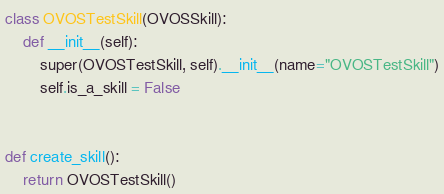<code> <loc_0><loc_0><loc_500><loc_500><_Python_>class OVOSTestSkill(OVOSSkill):
    def __init__(self):
        super(OVOSTestSkill, self).__init__(name="OVOSTestSkill")
        self.is_a_skill = False


def create_skill():
    return OVOSTestSkill()
</code> 